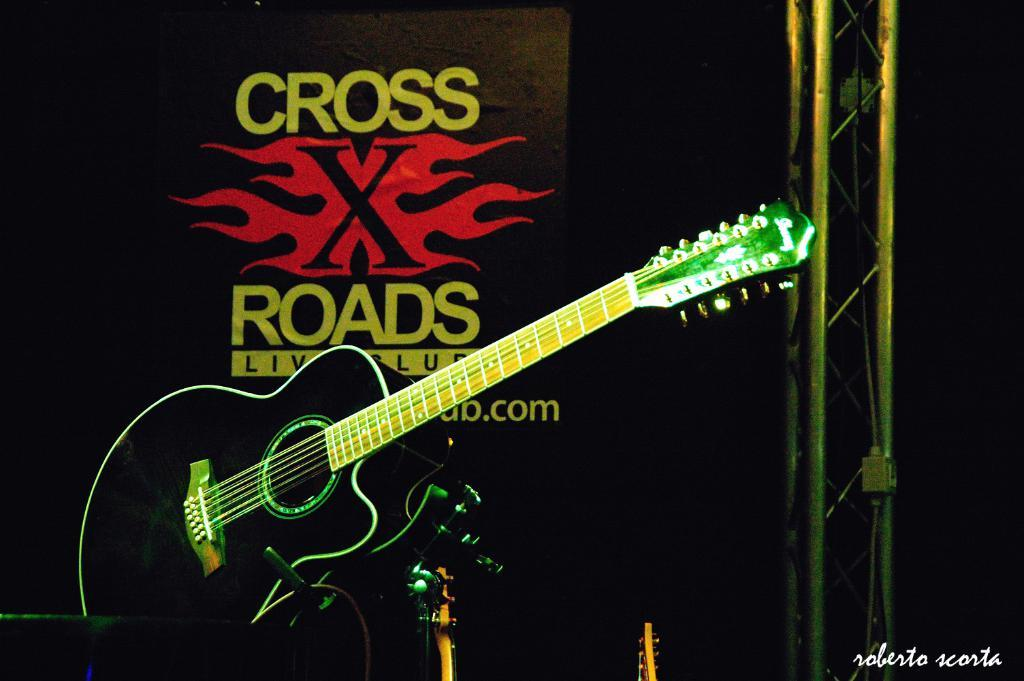What is the main object in the foreground of the image? There is a guitar in the foreground of the image. What can be seen on the right side of the image? There is an unspecified object on the right side of the image. What is visible in the background of the image? There is a logo with some names in the background of the image. What type of seed is being planted in the image? There is no seed or planting activity present in the image. What holiday is being celebrated in the image? There is no indication of a holiday being celebrated in the image. 